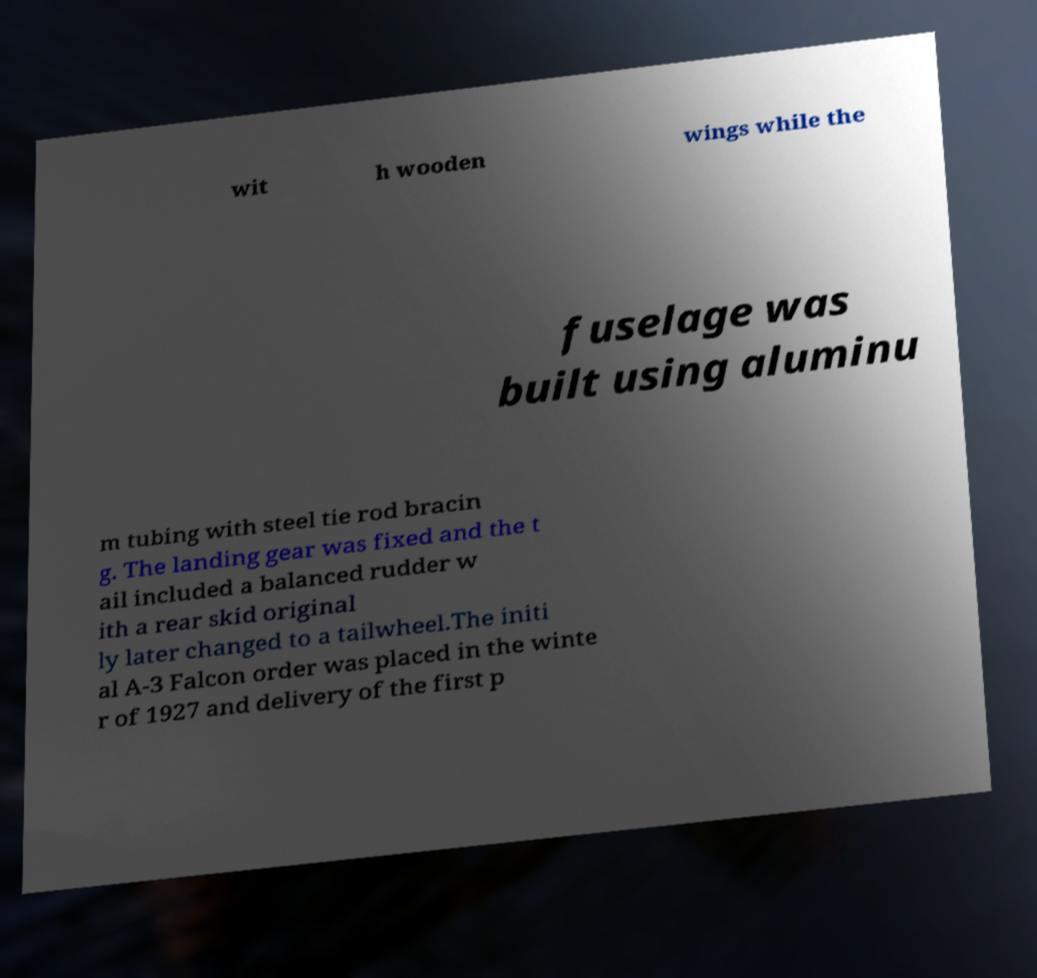What messages or text are displayed in this image? I need them in a readable, typed format. wit h wooden wings while the fuselage was built using aluminu m tubing with steel tie rod bracin g. The landing gear was fixed and the t ail included a balanced rudder w ith a rear skid original ly later changed to a tailwheel.The initi al A-3 Falcon order was placed in the winte r of 1927 and delivery of the first p 